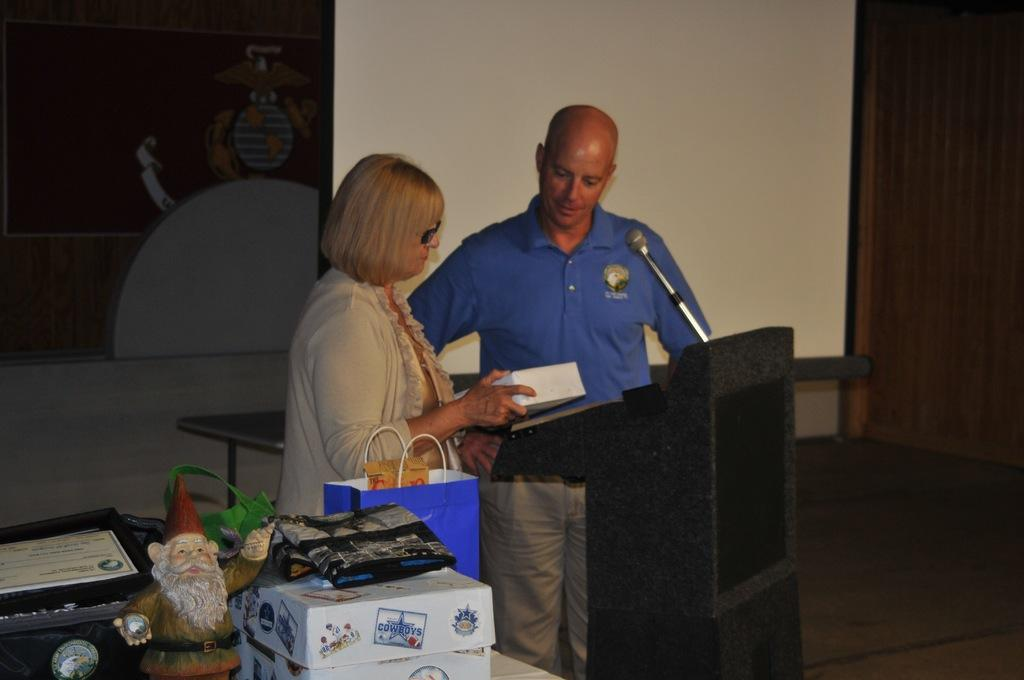How many people are in the image? There are two persons standing in the image. What is the purpose of the object in front of the two persons? There is a microphone (mic) in front of the two persons, which suggests they might be speaking or performing. Can you describe any other objects present in the image? There are other objects present in the left corner of the image, but their specific details are not mentioned in the provided facts. What type of industry is depicted in the image? There is no industry depicted in the image; it features two persons standing with a microphone in front of them. How does the transport system function in the image? There is no transport system present in the image; it only shows two persons and a microphone. 